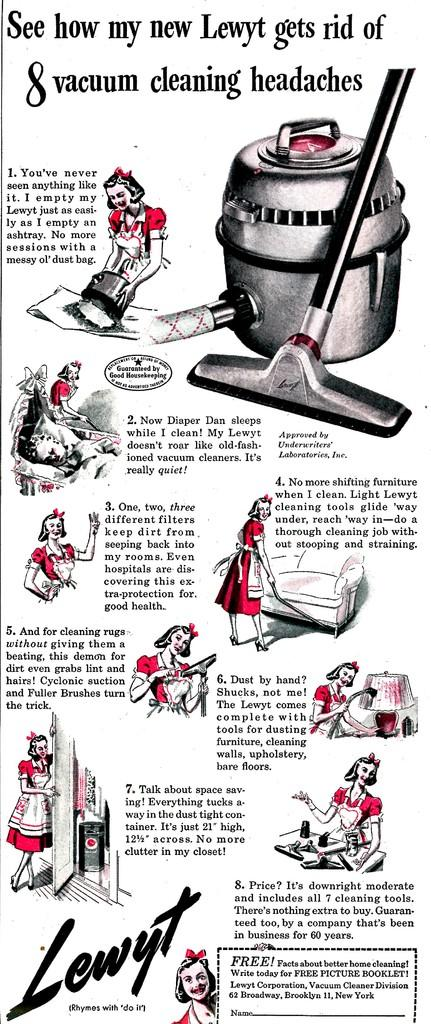<image>
Relay a brief, clear account of the picture shown. A vintage ad for Lewyt vacuum cleaners with illustrations. 